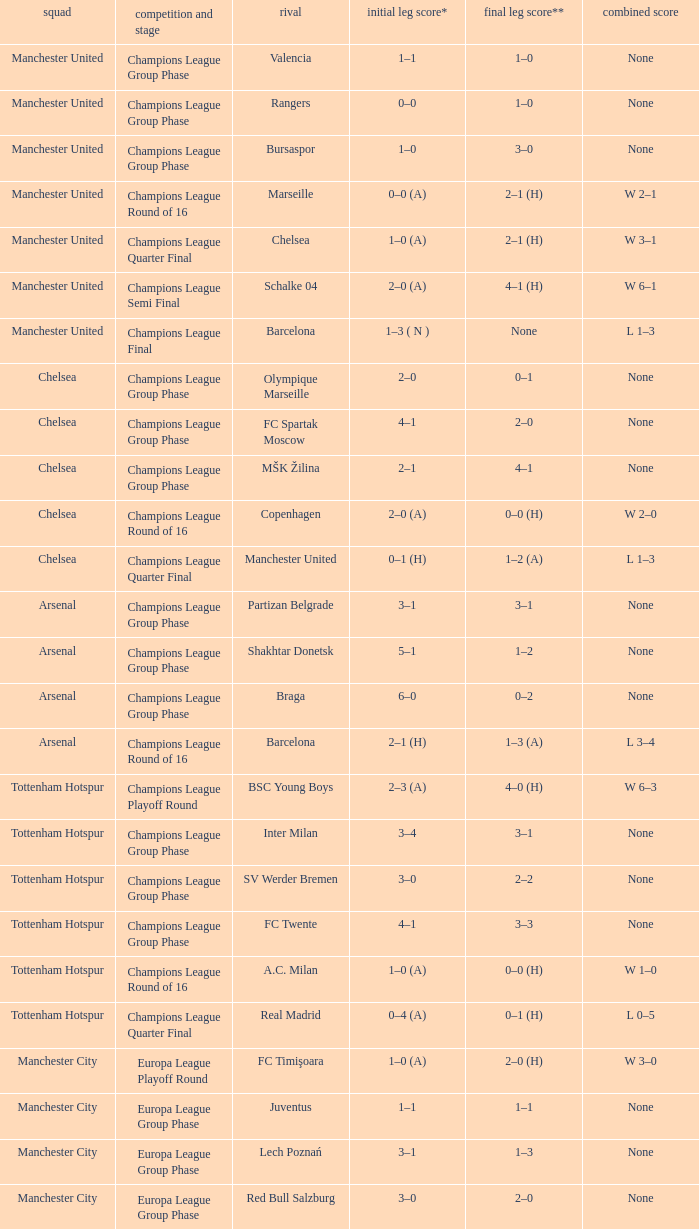What was the score between Marseille and Manchester United on the second leg of the Champions League Round of 16? 2–1 (H). 